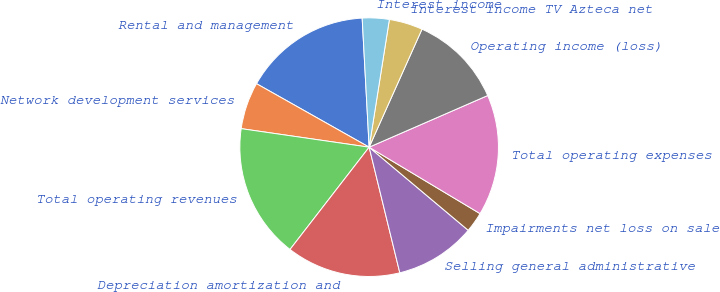Convert chart to OTSL. <chart><loc_0><loc_0><loc_500><loc_500><pie_chart><fcel>Rental and management<fcel>Network development services<fcel>Total operating revenues<fcel>Depreciation amortization and<fcel>Selling general administrative<fcel>Impairments net loss on sale<fcel>Total operating expenses<fcel>Operating income (loss)<fcel>Interest income TV Azteca net<fcel>Interest income<nl><fcel>15.97%<fcel>5.88%<fcel>16.81%<fcel>14.29%<fcel>10.08%<fcel>2.52%<fcel>15.13%<fcel>11.76%<fcel>4.2%<fcel>3.36%<nl></chart> 